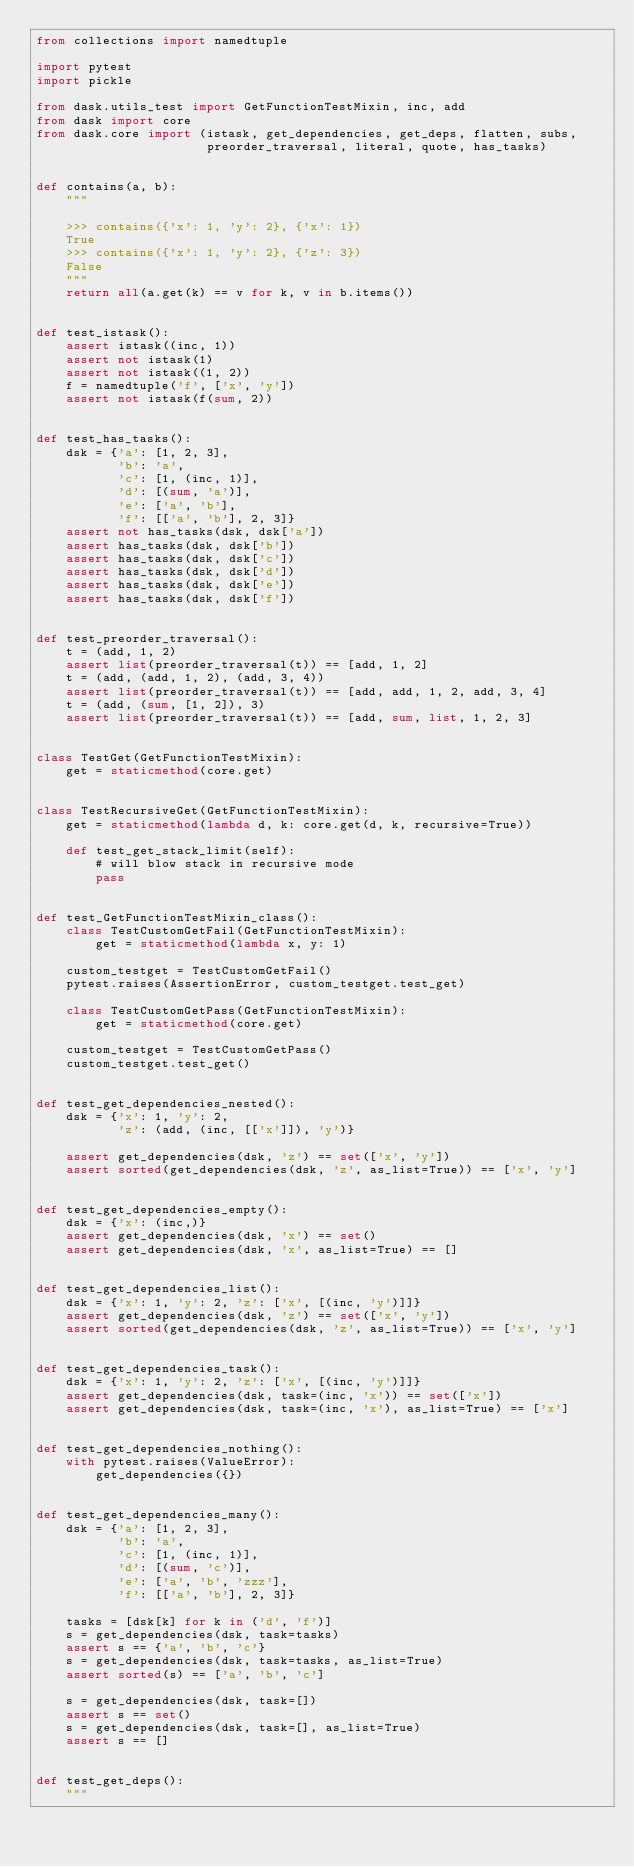<code> <loc_0><loc_0><loc_500><loc_500><_Python_>from collections import namedtuple

import pytest
import pickle

from dask.utils_test import GetFunctionTestMixin, inc, add
from dask import core
from dask.core import (istask, get_dependencies, get_deps, flatten, subs,
                       preorder_traversal, literal, quote, has_tasks)


def contains(a, b):
    """

    >>> contains({'x': 1, 'y': 2}, {'x': 1})
    True
    >>> contains({'x': 1, 'y': 2}, {'z': 3})
    False
    """
    return all(a.get(k) == v for k, v in b.items())


def test_istask():
    assert istask((inc, 1))
    assert not istask(1)
    assert not istask((1, 2))
    f = namedtuple('f', ['x', 'y'])
    assert not istask(f(sum, 2))


def test_has_tasks():
    dsk = {'a': [1, 2, 3],
           'b': 'a',
           'c': [1, (inc, 1)],
           'd': [(sum, 'a')],
           'e': ['a', 'b'],
           'f': [['a', 'b'], 2, 3]}
    assert not has_tasks(dsk, dsk['a'])
    assert has_tasks(dsk, dsk['b'])
    assert has_tasks(dsk, dsk['c'])
    assert has_tasks(dsk, dsk['d'])
    assert has_tasks(dsk, dsk['e'])
    assert has_tasks(dsk, dsk['f'])


def test_preorder_traversal():
    t = (add, 1, 2)
    assert list(preorder_traversal(t)) == [add, 1, 2]
    t = (add, (add, 1, 2), (add, 3, 4))
    assert list(preorder_traversal(t)) == [add, add, 1, 2, add, 3, 4]
    t = (add, (sum, [1, 2]), 3)
    assert list(preorder_traversal(t)) == [add, sum, list, 1, 2, 3]


class TestGet(GetFunctionTestMixin):
    get = staticmethod(core.get)


class TestRecursiveGet(GetFunctionTestMixin):
    get = staticmethod(lambda d, k: core.get(d, k, recursive=True))

    def test_get_stack_limit(self):
        # will blow stack in recursive mode
        pass


def test_GetFunctionTestMixin_class():
    class TestCustomGetFail(GetFunctionTestMixin):
        get = staticmethod(lambda x, y: 1)

    custom_testget = TestCustomGetFail()
    pytest.raises(AssertionError, custom_testget.test_get)

    class TestCustomGetPass(GetFunctionTestMixin):
        get = staticmethod(core.get)

    custom_testget = TestCustomGetPass()
    custom_testget.test_get()


def test_get_dependencies_nested():
    dsk = {'x': 1, 'y': 2,
           'z': (add, (inc, [['x']]), 'y')}

    assert get_dependencies(dsk, 'z') == set(['x', 'y'])
    assert sorted(get_dependencies(dsk, 'z', as_list=True)) == ['x', 'y']


def test_get_dependencies_empty():
    dsk = {'x': (inc,)}
    assert get_dependencies(dsk, 'x') == set()
    assert get_dependencies(dsk, 'x', as_list=True) == []


def test_get_dependencies_list():
    dsk = {'x': 1, 'y': 2, 'z': ['x', [(inc, 'y')]]}
    assert get_dependencies(dsk, 'z') == set(['x', 'y'])
    assert sorted(get_dependencies(dsk, 'z', as_list=True)) == ['x', 'y']


def test_get_dependencies_task():
    dsk = {'x': 1, 'y': 2, 'z': ['x', [(inc, 'y')]]}
    assert get_dependencies(dsk, task=(inc, 'x')) == set(['x'])
    assert get_dependencies(dsk, task=(inc, 'x'), as_list=True) == ['x']


def test_get_dependencies_nothing():
    with pytest.raises(ValueError):
        get_dependencies({})


def test_get_dependencies_many():
    dsk = {'a': [1, 2, 3],
           'b': 'a',
           'c': [1, (inc, 1)],
           'd': [(sum, 'c')],
           'e': ['a', 'b', 'zzz'],
           'f': [['a', 'b'], 2, 3]}

    tasks = [dsk[k] for k in ('d', 'f')]
    s = get_dependencies(dsk, task=tasks)
    assert s == {'a', 'b', 'c'}
    s = get_dependencies(dsk, task=tasks, as_list=True)
    assert sorted(s) == ['a', 'b', 'c']

    s = get_dependencies(dsk, task=[])
    assert s == set()
    s = get_dependencies(dsk, task=[], as_list=True)
    assert s == []


def test_get_deps():
    """</code> 